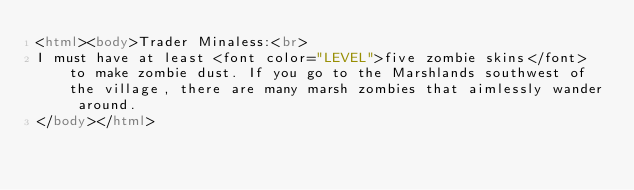<code> <loc_0><loc_0><loc_500><loc_500><_HTML_><html><body>Trader Minaless:<br>
I must have at least <font color="LEVEL">five zombie skins</font> to make zombie dust. If you go to the Marshlands southwest of the village, there are many marsh zombies that aimlessly wander around. 
</body></html></code> 